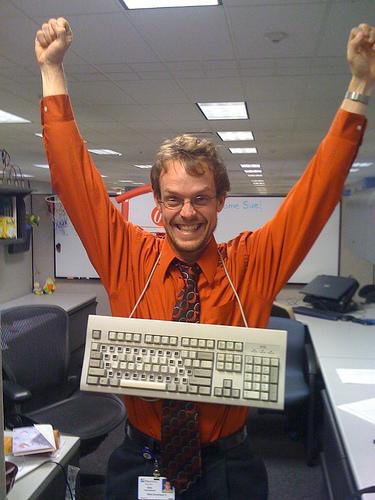What color is the man's shirt?
Short answer required. Orange. Was the picture taken in an office?
Write a very short answer. Yes. What is around this person's neck?
Quick response, please. Keyboard. 